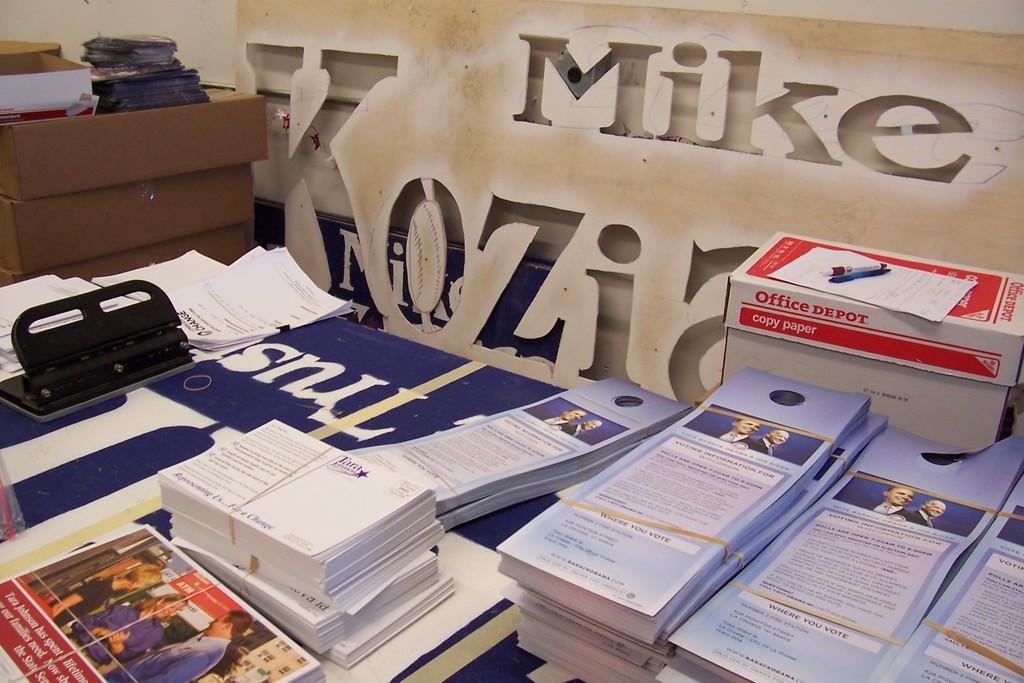Where is the red box from?
Offer a very short reply. Office depot. 